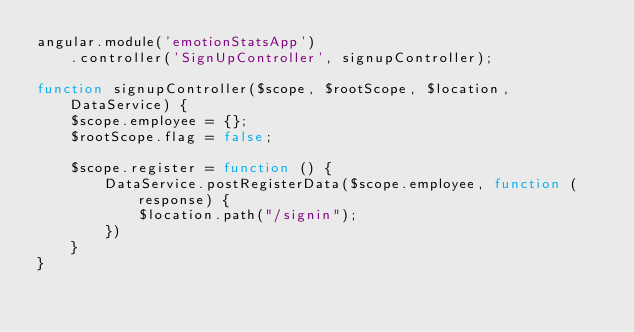<code> <loc_0><loc_0><loc_500><loc_500><_JavaScript_>angular.module('emotionStatsApp')
    .controller('SignUpController', signupController);

function signupController($scope, $rootScope, $location, DataService) {
    $scope.employee = {};
    $rootScope.flag = false;

    $scope.register = function () {
        DataService.postRegisterData($scope.employee, function (response) {
            $location.path("/signin");
        })
    }
}
</code> 